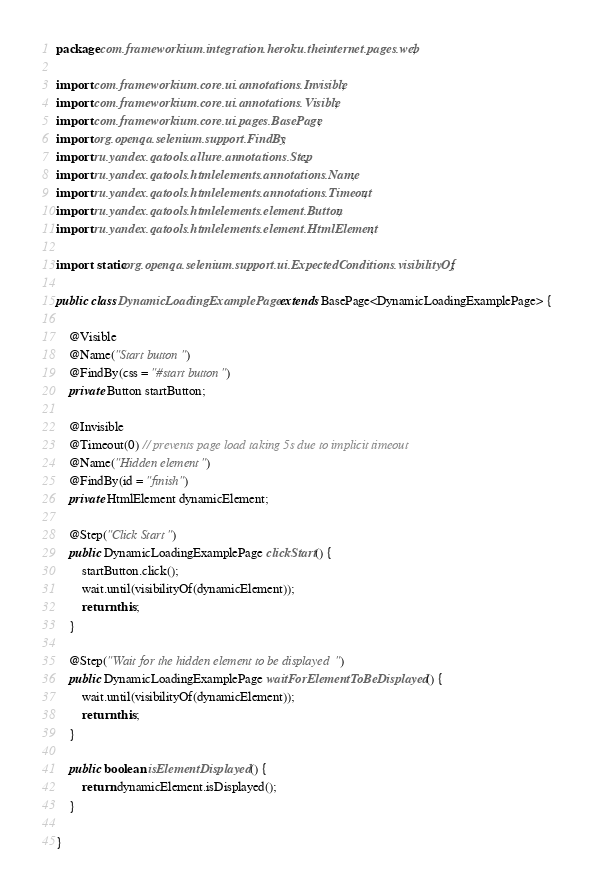<code> <loc_0><loc_0><loc_500><loc_500><_Java_>package com.frameworkium.integration.heroku.theinternet.pages.web;

import com.frameworkium.core.ui.annotations.Invisible;
import com.frameworkium.core.ui.annotations.Visible;
import com.frameworkium.core.ui.pages.BasePage;
import org.openqa.selenium.support.FindBy;
import ru.yandex.qatools.allure.annotations.Step;
import ru.yandex.qatools.htmlelements.annotations.Name;
import ru.yandex.qatools.htmlelements.annotations.Timeout;
import ru.yandex.qatools.htmlelements.element.Button;
import ru.yandex.qatools.htmlelements.element.HtmlElement;

import static org.openqa.selenium.support.ui.ExpectedConditions.visibilityOf;

public class DynamicLoadingExamplePage extends BasePage<DynamicLoadingExamplePage> {

    @Visible
    @Name("Start button")
    @FindBy(css = "#start button")
    private Button startButton;

    @Invisible
    @Timeout(0) // prevents page load taking 5s due to implicit timeout
    @Name("Hidden element")
    @FindBy(id = "finish")
    private HtmlElement dynamicElement;

    @Step("Click Start")
    public DynamicLoadingExamplePage clickStart() {
        startButton.click();
        wait.until(visibilityOf(dynamicElement));
        return this;
    }

    @Step("Wait for the hidden element to be displayed")
    public DynamicLoadingExamplePage waitForElementToBeDisplayed() {
        wait.until(visibilityOf(dynamicElement));
        return this;
    }

    public boolean isElementDisplayed() {
        return dynamicElement.isDisplayed();
    }

}
</code> 